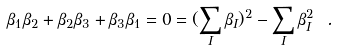<formula> <loc_0><loc_0><loc_500><loc_500>\beta _ { 1 } \beta _ { 2 } + \beta _ { 2 } \beta _ { 3 } + \beta _ { 3 } \beta _ { 1 } = 0 = ( \sum _ { I } \beta _ { I } ) ^ { 2 } - \sum _ { I } \beta _ { I } ^ { 2 } \ .</formula> 